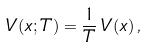<formula> <loc_0><loc_0><loc_500><loc_500>V ( x ; T ) = \frac { 1 } { T } \, V ( x ) \, ,</formula> 